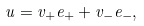<formula> <loc_0><loc_0><loc_500><loc_500>u = v _ { + } e _ { + } + v _ { - } e _ { - } ,</formula> 